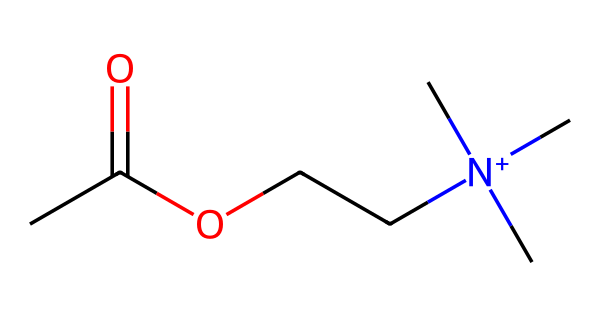What is the molecular formula of this chemical? By analyzing the SMILES representation, the components can be counted: There are 7 carbon (C), 16 hydrogen (H), 2 oxygen (O), and 1 nitrogen (N) atom. We combine these to generate the molecular formula: C7H16N1O2.
Answer: C7H16N1O2 How many carbon atoms are present? The SMILES indicates the carbon backbone, and by counting 'C' in the structure, we find there are 7 carbon atoms present.
Answer: 7 Is this molecule positively charged? The presence of the nitrogen atom attached to three carbons (indicated by [N+](C)(C)C) suggests that nitrogen carries a positive charge in this molecule.
Answer: Yes What functional groups are present in acetylcholine? The molecule contains an acetate group (as indicated by the 'CC(=O)O' part) and a quaternary ammonium group due to the nitrogen being positively charged and bound to three alkyl groups.
Answer: Acetate and quaternary ammonium What type of biochemical role does acetylcholine primarily serve? Acetylcholine functions as a neurotransmitter in the nervous system, facilitating signal transmission, particularly in memory and learning processes.
Answer: Neurotransmitter What is the significance of acetylcholine in learning? Acetylcholine plays a critical role in the formation of memories and learning new information, including songs and chants, by transmitting signals between neurons.
Answer: Memory formation 